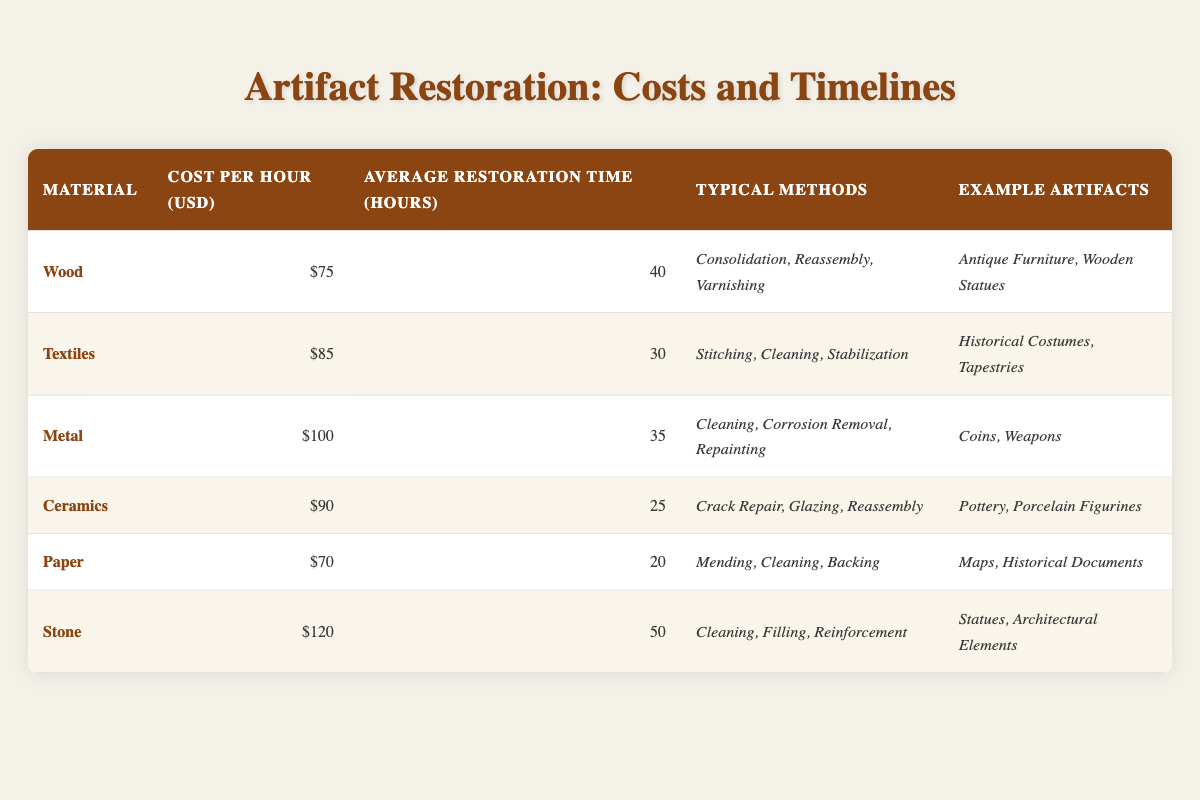What is the cost per hour for wood restoration? In the table, the cost per hour for wood restoration is listed under the "Cost Per Hour (USD)" column for the "Wood" material row, which shows $75.
Answer: $75 Which material has the highest average restoration time? By comparing the values in the "Average Restoration Time (Hours)" column, Stone has the highest at 50 hours, which is greater than all other materials.
Answer: Stone How much does it cost to restore 10 hours of metal artifacts? The cost per hour for metal restoration is $100. Therefore, for 10 hours, the total cost is calculated as 10 hours * $100/hour = $1000.
Answer: $1000 Is the average restoration time for ceramics less than 30 hours? The average restoration time for ceramics is 25 hours, which is indeed less than 30 hours. Thus, the statement is true.
Answer: Yes What is the average cost per hour for all the materials listed? To find the average cost per hour, sum all the costs: 75 + 85 + 100 + 90 + 70 + 120 = 540. Then divide this sum by the number of materials (6), resulting in an average cost of 540/6 = 90.
Answer: $90 Which two materials have the same typical methods of restoration? By examining the "Typical Methods" column, none of the materials share the exact same typical methods; each has unique processes outlined.
Answer: No If we consider only paper and ceramics, what is the total restoration time in hours? The average restoration time for paper is 20 hours and for ceramics is 25 hours. Adding these two gives us 20 + 25 = 45 hours of total restoration time.
Answer: 45 hours Are wooden statues included in the example artifacts for wood restoration? Yes, wooden statues are listed under the "Example Artifacts" for wood restoration.
Answer: Yes How many artifacts can be restored with a budget of $500 if we focus solely on paper restoration? The cost per hour for paper restoration is $70. Therefore, with a budget of $500, the total hours possible are 500 / 70 ≈ 7.14, which means approximately 7 hours can be dedicated, restoring artifacts accordingly but possibly not a full artifact if not meeting the minimum hours.
Answer: 7 hours 